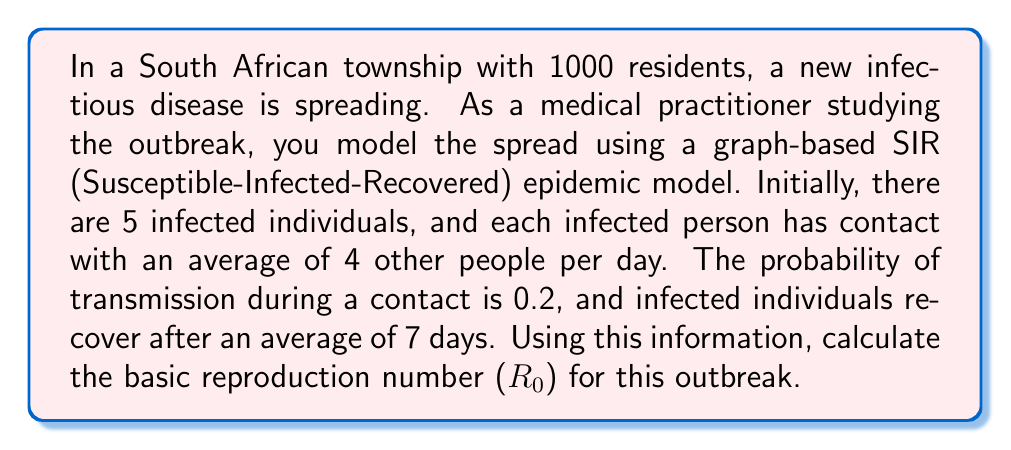Give your solution to this math problem. To solve this problem, we need to understand the components of the basic reproduction number ($R_0$) in a graph-based SIR model:

1. The basic reproduction number ($R_0$) is defined as the average number of secondary infections caused by a single infected individual in a completely susceptible population.

2. In a graph-based model, $R_0$ can be calculated using the following formula:

   $$R_0 = \beta \cdot k \cdot D$$

   Where:
   - $\beta$ is the probability of transmission per contact
   - $k$ is the average number of contacts per day
   - $D$ is the average duration of infectiousness in days

3. From the given information:
   - $\beta = 0.2$
   - $k = 4$
   - $D = 7$ days

4. Now, we can substitute these values into the formula:

   $$R_0 = 0.2 \cdot 4 \cdot 7$$

5. Calculating:
   $$R_0 = 0.8 \cdot 7 = 5.6$$

This $R_0$ value indicates that, on average, each infected person will infect 5.6 others during their infectious period in a fully susceptible population.
Answer: $R_0 = 5.6$ 